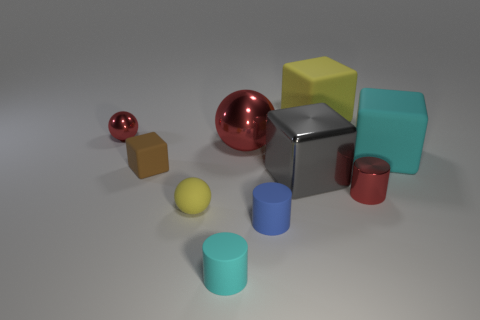Subtract all cubes. How many objects are left? 6 Subtract 1 gray cubes. How many objects are left? 9 Subtract all large metal objects. Subtract all large yellow things. How many objects are left? 7 Add 6 large yellow rubber blocks. How many large yellow rubber blocks are left? 7 Add 8 big yellow rubber cylinders. How many big yellow rubber cylinders exist? 8 